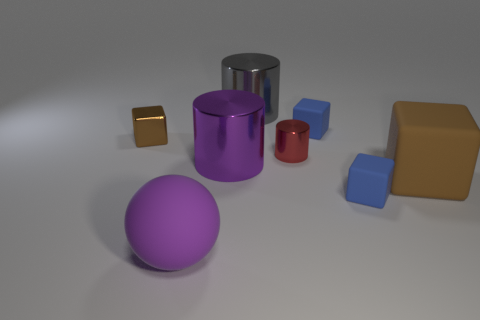Is there anything else that is the same shape as the small red metal object?
Your answer should be compact. Yes. Is there a green ball?
Give a very brief answer. No. Are there fewer tiny brown metallic blocks than large rubber objects?
Your response must be concise. Yes. What number of tiny cubes are made of the same material as the large purple cylinder?
Keep it short and to the point. 1. The ball that is made of the same material as the big cube is what color?
Make the answer very short. Purple. What is the shape of the big gray metal thing?
Offer a very short reply. Cylinder. How many objects have the same color as the tiny metal block?
Provide a short and direct response. 1. What shape is the gray shiny object that is the same size as the brown matte cube?
Give a very brief answer. Cylinder. Are there any purple spheres of the same size as the red thing?
Ensure brevity in your answer.  No. What material is the purple sphere that is the same size as the gray thing?
Your answer should be very brief. Rubber. 